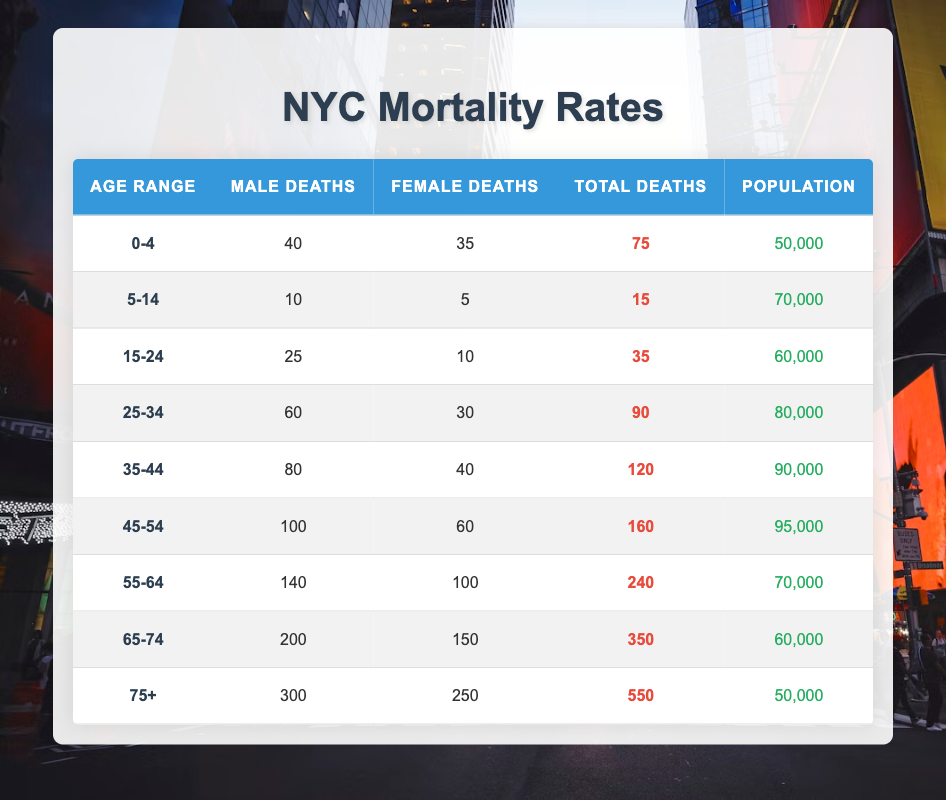What is the total number of deaths for the age group 45-54? The table shows that for the age range 45-54, the total deaths are listed as 160.
Answer: 160 How many female deaths are recorded in the age group 25-34? According to the table, the number of female deaths in the age range 25-34 is 30.
Answer: 30 Which age group has the highest number of male deaths? The table indicates that the age group 75+ has the highest number of male deaths, recorded as 300.
Answer: 75+ What is the total population of the age group 65-74? The population for the age range 65-74 in the table is specified as 60,000.
Answer: 60,000 Is it true that there are more than 200 total deaths in the age range 55-64? The table shows that the total deaths for the age range 55-64 is 240, which is indeed more than 200.
Answer: Yes What is the average number of female deaths across all age groups? To find the average, add female deaths from all age groups: 35 + 5 + 10 + 30 + 40 + 60 + 100 + 150 + 250 = 680. Then divide by the number of age groups (9): 680/9 = approximately 75.56.
Answer: 75.56 How many more male deaths are there in the 75+ age group than in the 0-4 age group? The 75+ age group has 300 male deaths, and the 0-4 age group has 40. The difference is 300 - 40 = 260.
Answer: 260 What is the total death count of all males in the age groups 45-54 and 55-64 combined? For the age groups 45-54 and 55-64, the male deaths are 100 and 140 respectively. Adding these gives 100 + 140 = 240.
Answer: 240 Is the number of deaths higher for females or males in the age group 35-44? In the age group 35-44, there are 80 male deaths and 40 female deaths. This indicates that male deaths are higher.
Answer: Males are higher 